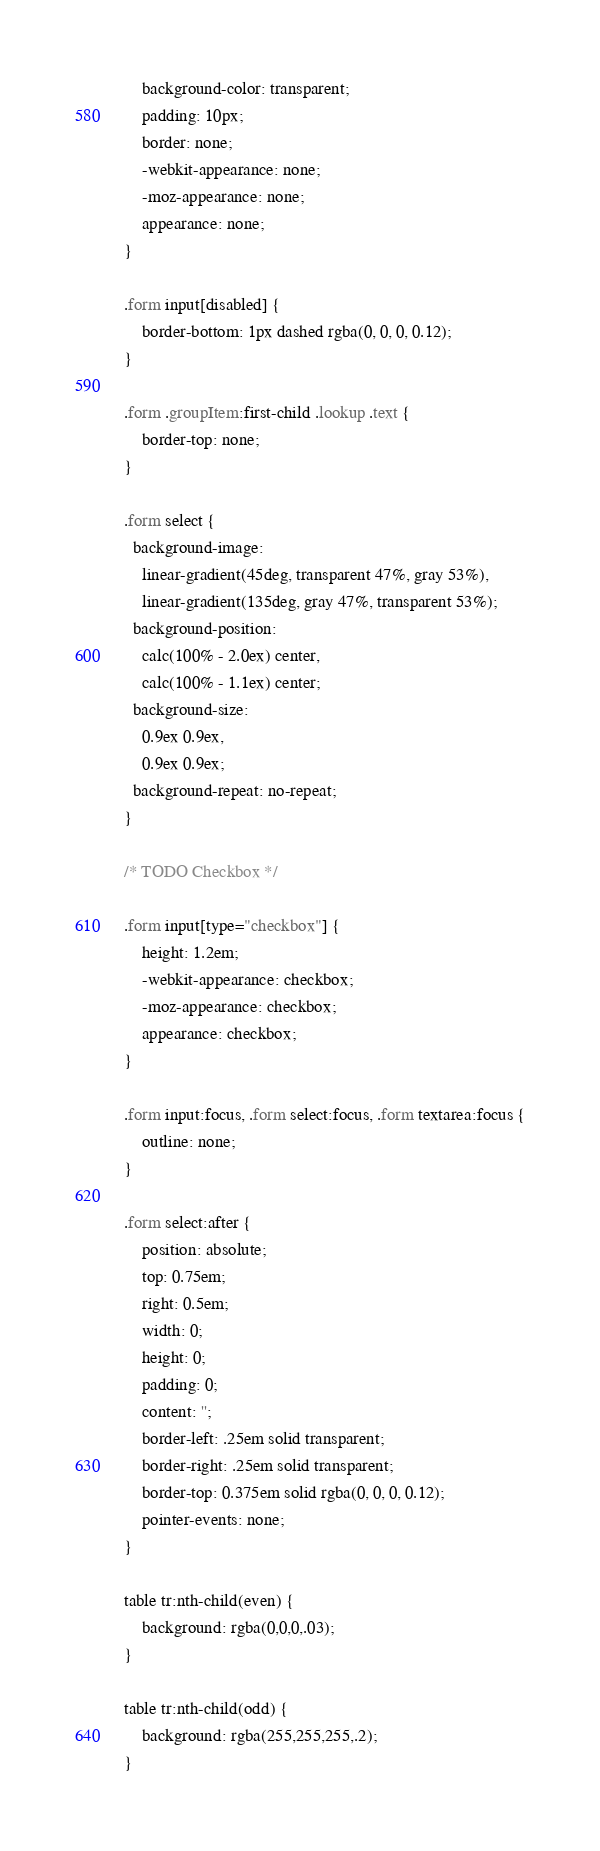Convert code to text. <code><loc_0><loc_0><loc_500><loc_500><_CSS_>	background-color: transparent;
	padding: 10px;
	border: none;
	-webkit-appearance: none;
	-moz-appearance: none;
	appearance: none;
}

.form input[disabled] {
	border-bottom: 1px dashed rgba(0, 0, 0, 0.12);
}

.form .groupItem:first-child .lookup .text {
	border-top: none;
}

.form select {
  background-image:
    linear-gradient(45deg, transparent 47%, gray 53%),
    linear-gradient(135deg, gray 47%, transparent 53%);
  background-position:
    calc(100% - 2.0ex) center,
    calc(100% - 1.1ex) center;
  background-size:
    0.9ex 0.9ex,
    0.9ex 0.9ex;
  background-repeat: no-repeat;
}

/* TODO Checkbox */

.form input[type="checkbox"] {
	height: 1.2em;
	-webkit-appearance: checkbox;
	-moz-appearance: checkbox;
	appearance: checkbox;
}

.form input:focus, .form select:focus, .form textarea:focus {
	outline: none;
}

.form select:after {
	position: absolute;
	top: 0.75em;
	right: 0.5em;
	width: 0;
	height: 0;
	padding: 0;
	content: '';
	border-left: .25em solid transparent;
	border-right: .25em solid transparent;
	border-top: 0.375em solid rgba(0, 0, 0, 0.12);
	pointer-events: none;
}

table tr:nth-child(even) {
	background: rgba(0,0,0,.03);
}

table tr:nth-child(odd) {
	background: rgba(255,255,255,.2);
}</code> 